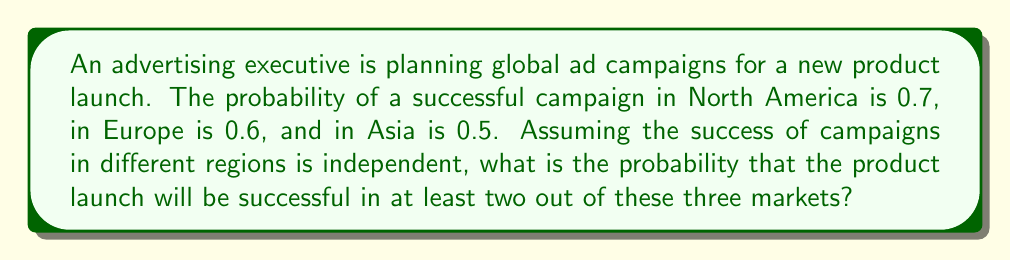Can you answer this question? Let's approach this step-by-step:

1) First, we need to calculate the probability of success in at least two markets. This can be done by calculating the probability of success in:
   a) All three markets
   b) Exactly two markets

2) Let's define events:
   N: Success in North America
   E: Success in Europe
   A: Success in Asia

3) Probability of success in all three markets:
   $$P(N \cap E \cap A) = 0.7 \times 0.6 \times 0.5 = 0.21$$

4) Probability of success in exactly two markets:
   a) Success in N and E, failure in A: 
      $$P(N \cap E \cap A^c) = 0.7 \times 0.6 \times 0.5 = 0.21$$
   b) Success in N and A, failure in E: 
      $$P(N \cap E^c \cap A) = 0.7 \times 0.4 \times 0.5 = 0.14$$
   c) Success in E and A, failure in N: 
      $$P(N^c \cap E \cap A) = 0.3 \times 0.6 \times 0.5 = 0.09$$

5) Total probability of success in exactly two markets:
   $$P(\text{exactly two}) = 0.21 + 0.14 + 0.09 = 0.44$$

6) Probability of success in at least two markets:
   $$P(\text{at least two}) = P(\text{all three}) + P(\text{exactly two})$$
   $$P(\text{at least two}) = 0.21 + 0.44 = 0.65$$

Therefore, the probability of a successful product launch in at least two out of these three markets is 0.65 or 65%.
Answer: 0.65 